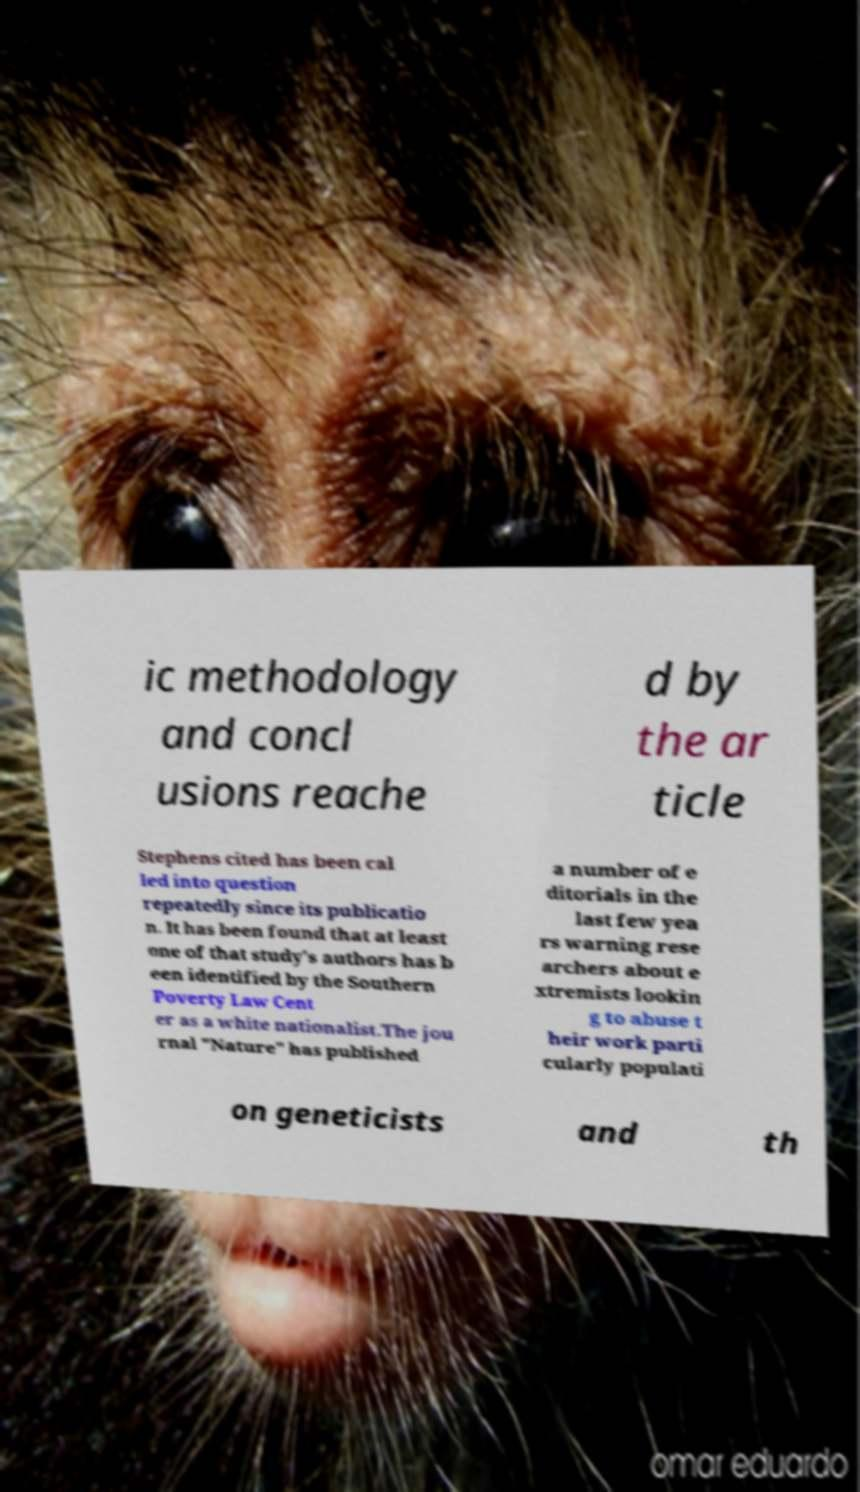Could you extract and type out the text from this image? ic methodology and concl usions reache d by the ar ticle Stephens cited has been cal led into question repeatedly since its publicatio n. It has been found that at least one of that study's authors has b een identified by the Southern Poverty Law Cent er as a white nationalist.The jou rnal "Nature" has published a number of e ditorials in the last few yea rs warning rese archers about e xtremists lookin g to abuse t heir work parti cularly populati on geneticists and th 